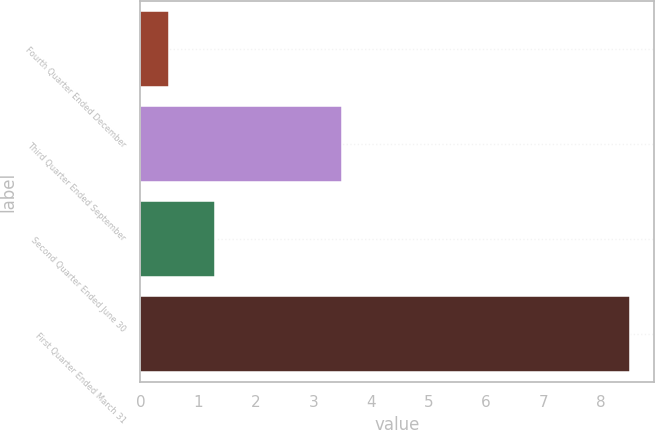Convert chart. <chart><loc_0><loc_0><loc_500><loc_500><bar_chart><fcel>Fourth Quarter Ended December<fcel>Third Quarter Ended September<fcel>Second Quarter Ended June 30<fcel>First Quarter Ended March 31<nl><fcel>0.5<fcel>3.5<fcel>1.3<fcel>8.5<nl></chart> 